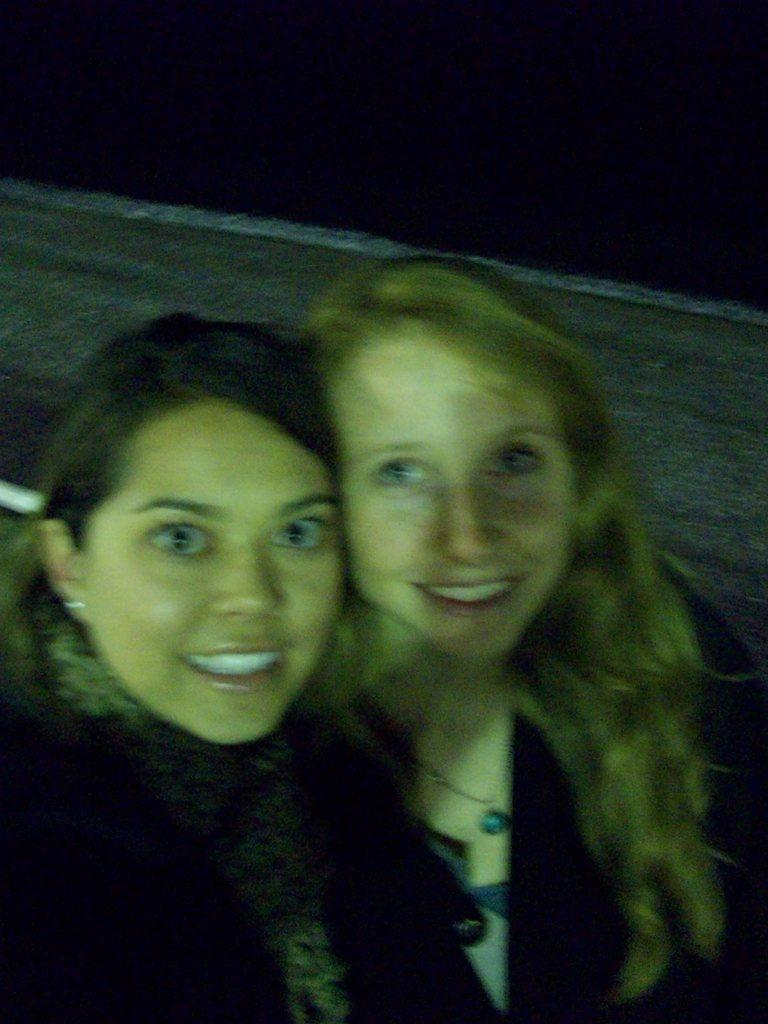How many people are in the image? There are two women in the image. What can be seen in the background of the image? The background of the image is black. What type of animals can be seen at the zoo in the image? There is no zoo present in the image, so it is not possible to determine what animals might be seen there. 